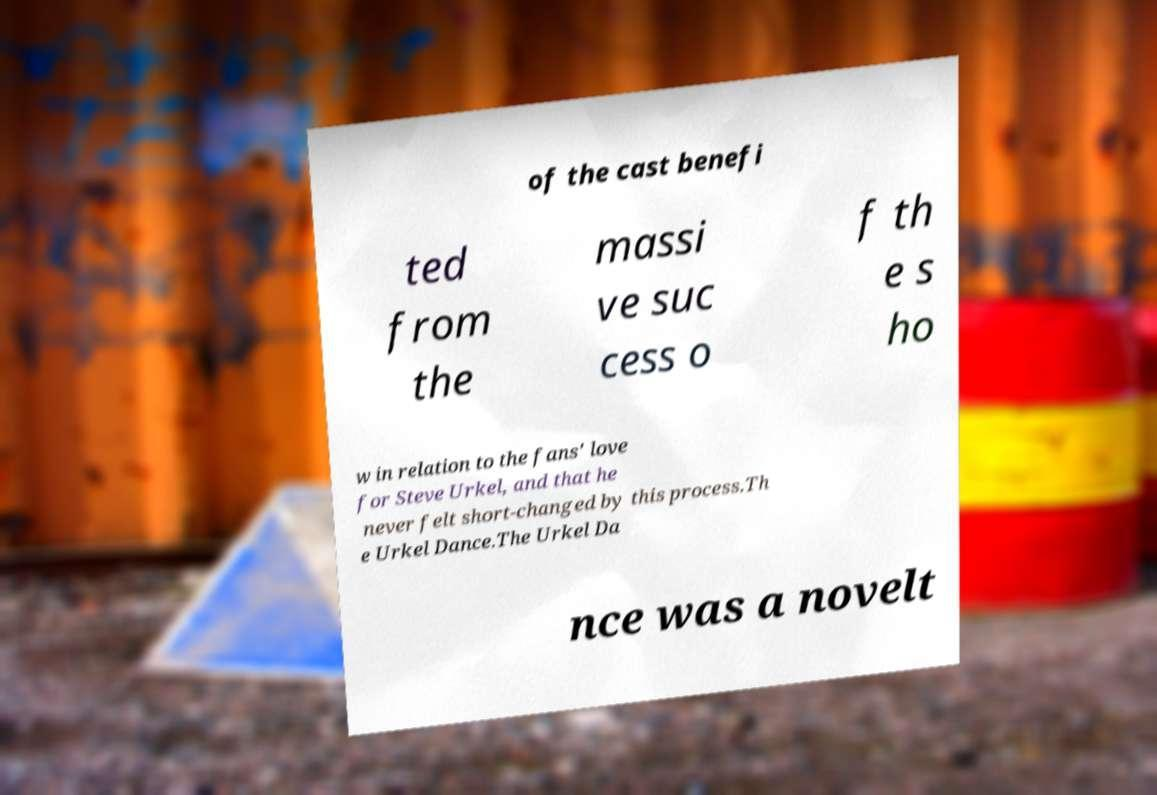Can you read and provide the text displayed in the image?This photo seems to have some interesting text. Can you extract and type it out for me? of the cast benefi ted from the massi ve suc cess o f th e s ho w in relation to the fans' love for Steve Urkel, and that he never felt short-changed by this process.Th e Urkel Dance.The Urkel Da nce was a novelt 